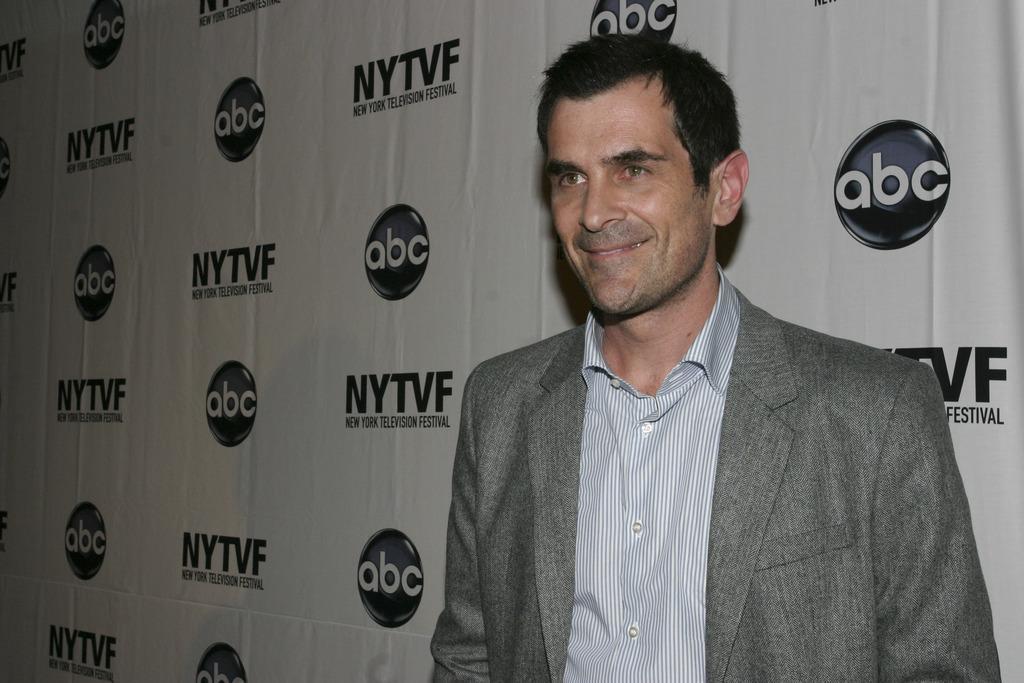How would you summarize this image in a sentence or two? In this image I can see a man in the front and I can see smile on his face. I can also see he is wearing a shirt and a blazer. Behind him I can see a white colour board and on it I can see something is written. 